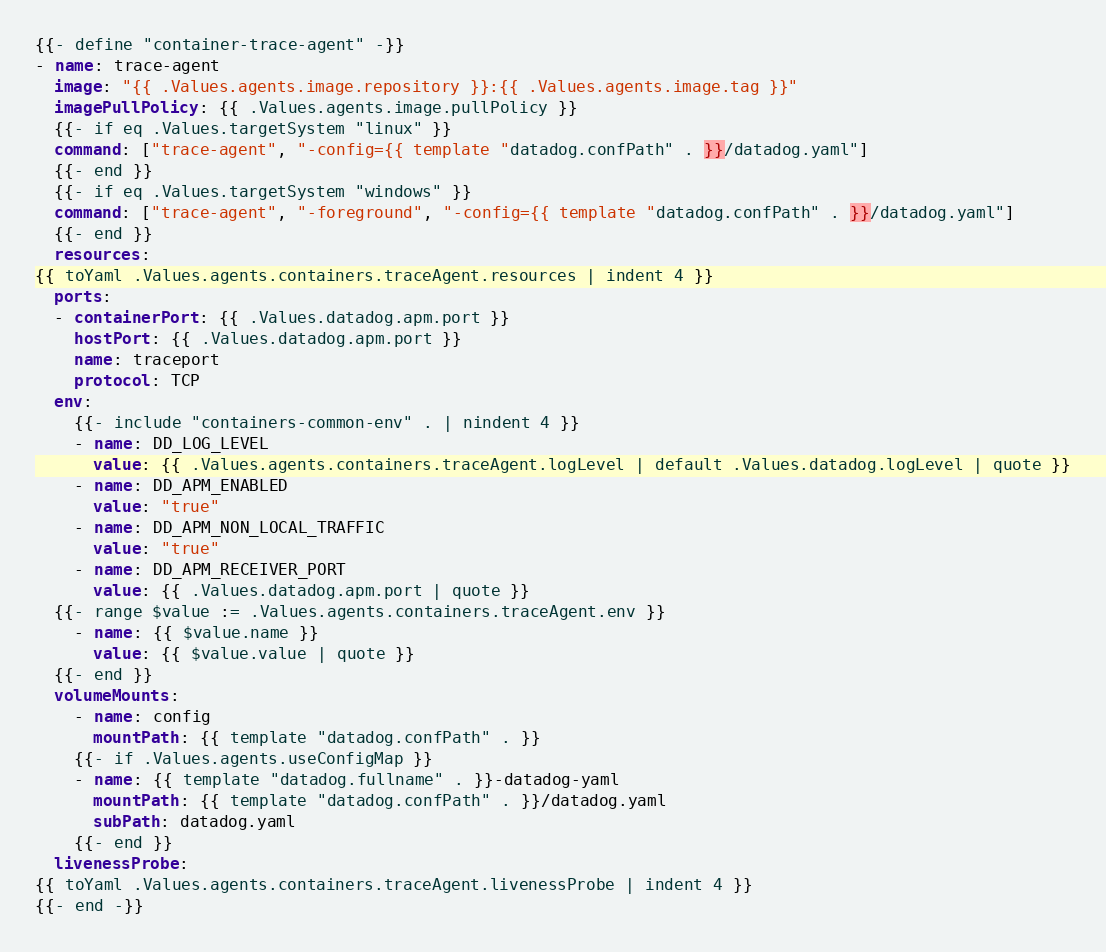Convert code to text. <code><loc_0><loc_0><loc_500><loc_500><_YAML_>{{- define "container-trace-agent" -}}
- name: trace-agent
  image: "{{ .Values.agents.image.repository }}:{{ .Values.agents.image.tag }}"
  imagePullPolicy: {{ .Values.agents.image.pullPolicy }}
  {{- if eq .Values.targetSystem "linux" }}
  command: ["trace-agent", "-config={{ template "datadog.confPath" . }}/datadog.yaml"]
  {{- end }}
  {{- if eq .Values.targetSystem "windows" }}
  command: ["trace-agent", "-foreground", "-config={{ template "datadog.confPath" . }}/datadog.yaml"]
  {{- end }}
  resources:
{{ toYaml .Values.agents.containers.traceAgent.resources | indent 4 }}
  ports:
  - containerPort: {{ .Values.datadog.apm.port }}
    hostPort: {{ .Values.datadog.apm.port }}
    name: traceport
    protocol: TCP
  env:
    {{- include "containers-common-env" . | nindent 4 }}
    - name: DD_LOG_LEVEL
      value: {{ .Values.agents.containers.traceAgent.logLevel | default .Values.datadog.logLevel | quote }}
    - name: DD_APM_ENABLED
      value: "true"
    - name: DD_APM_NON_LOCAL_TRAFFIC
      value: "true"
    - name: DD_APM_RECEIVER_PORT
      value: {{ .Values.datadog.apm.port | quote }}
  {{- range $value := .Values.agents.containers.traceAgent.env }}
    - name: {{ $value.name }}
      value: {{ $value.value | quote }}
  {{- end }}
  volumeMounts:
    - name: config
      mountPath: {{ template "datadog.confPath" . }}
    {{- if .Values.agents.useConfigMap }}
    - name: {{ template "datadog.fullname" . }}-datadog-yaml
      mountPath: {{ template "datadog.confPath" . }}/datadog.yaml
      subPath: datadog.yaml
    {{- end }}
  livenessProbe:
{{ toYaml .Values.agents.containers.traceAgent.livenessProbe | indent 4 }}
{{- end -}}
</code> 